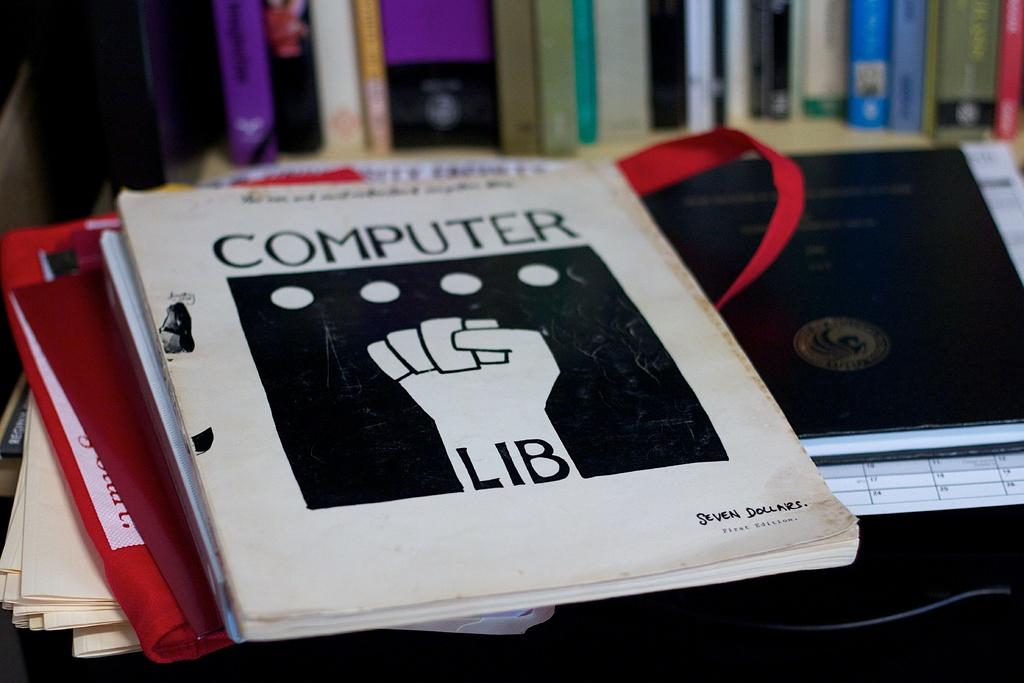Provide a one-sentence caption for the provided image. A textbook on a desk titled Computer Lib. 